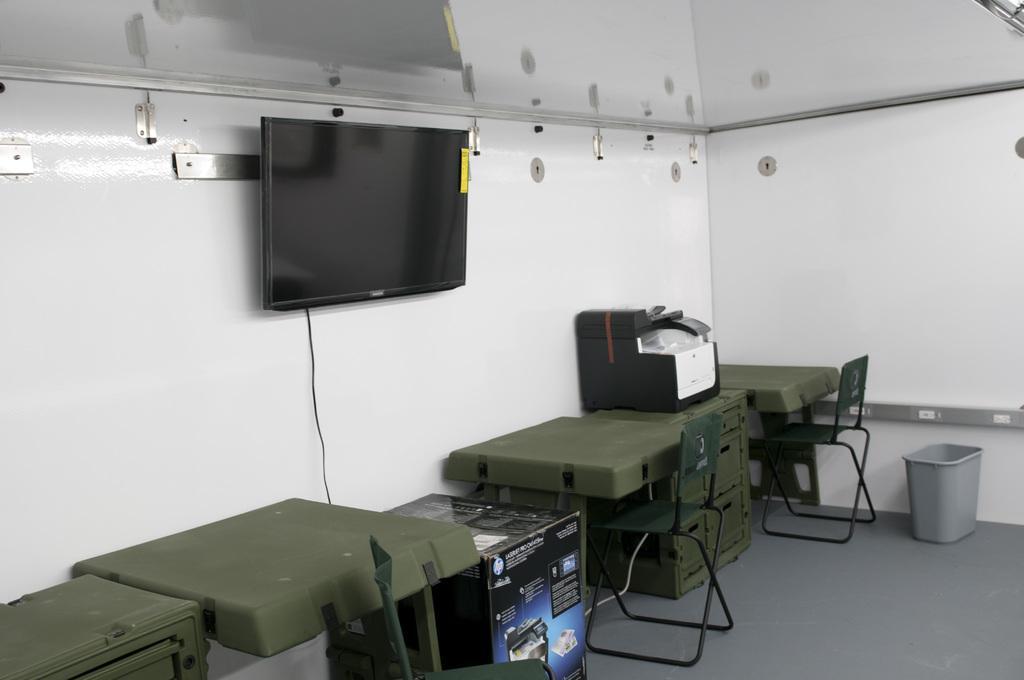Describe this image in one or two sentences. In this image we can see tables, chairs, printer, bin, television on the wall and other objects. At the top of the image there is the ceiling with some reflections. At the bottom of the image there is the floor. 